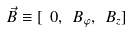Convert formula to latex. <formula><loc_0><loc_0><loc_500><loc_500>\vec { B } \equiv [ \ 0 , \ B _ { \varphi } , \ B _ { z } ]</formula> 